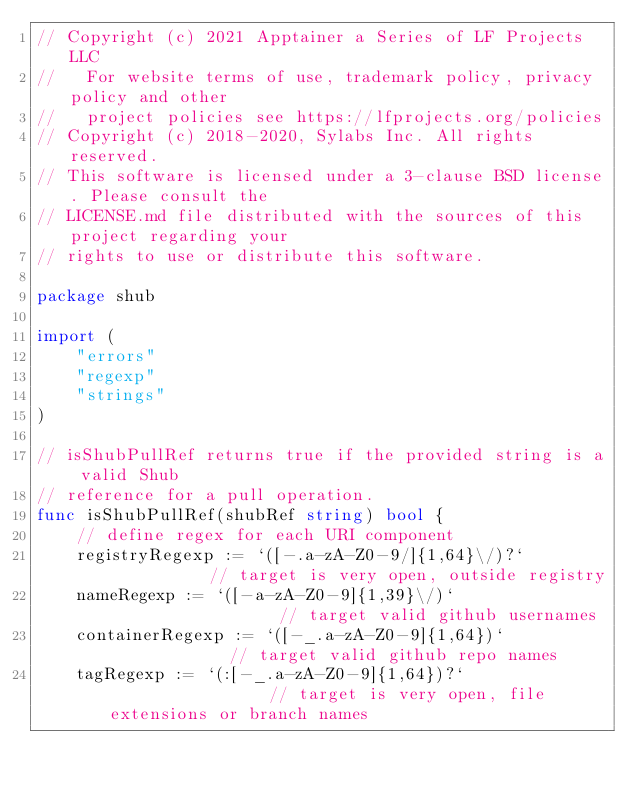<code> <loc_0><loc_0><loc_500><loc_500><_Go_>// Copyright (c) 2021 Apptainer a Series of LF Projects LLC
//   For website terms of use, trademark policy, privacy policy and other
//   project policies see https://lfprojects.org/policies
// Copyright (c) 2018-2020, Sylabs Inc. All rights reserved.
// This software is licensed under a 3-clause BSD license. Please consult the
// LICENSE.md file distributed with the sources of this project regarding your
// rights to use or distribute this software.

package shub

import (
	"errors"
	"regexp"
	"strings"
)

// isShubPullRef returns true if the provided string is a valid Shub
// reference for a pull operation.
func isShubPullRef(shubRef string) bool {
	// define regex for each URI component
	registryRegexp := `([-.a-zA-Z0-9/]{1,64}\/)?`           // target is very open, outside registry
	nameRegexp := `([-a-zA-Z0-9]{1,39}\/)`                  // target valid github usernames
	containerRegexp := `([-_.a-zA-Z0-9]{1,64})`             // target valid github repo names
	tagRegexp := `(:[-_.a-zA-Z0-9]{1,64})?`                 // target is very open, file extensions or branch names</code> 